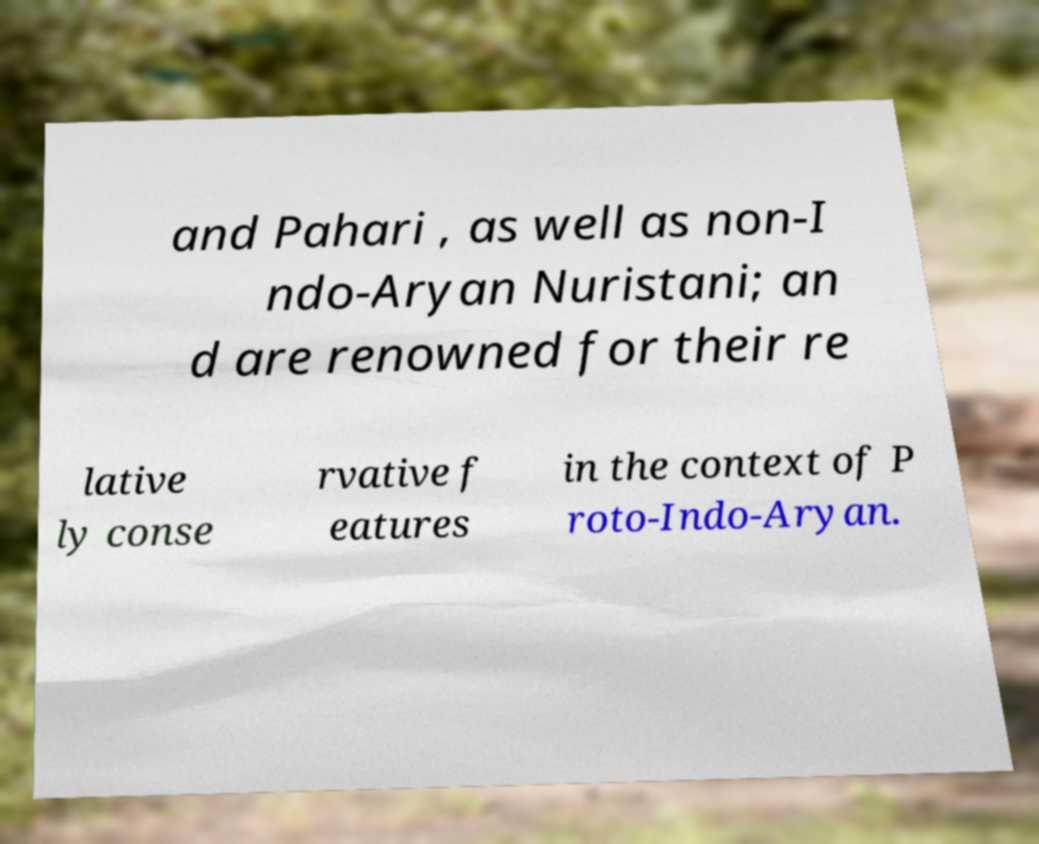Can you accurately transcribe the text from the provided image for me? and Pahari , as well as non-I ndo-Aryan Nuristani; an d are renowned for their re lative ly conse rvative f eatures in the context of P roto-Indo-Aryan. 